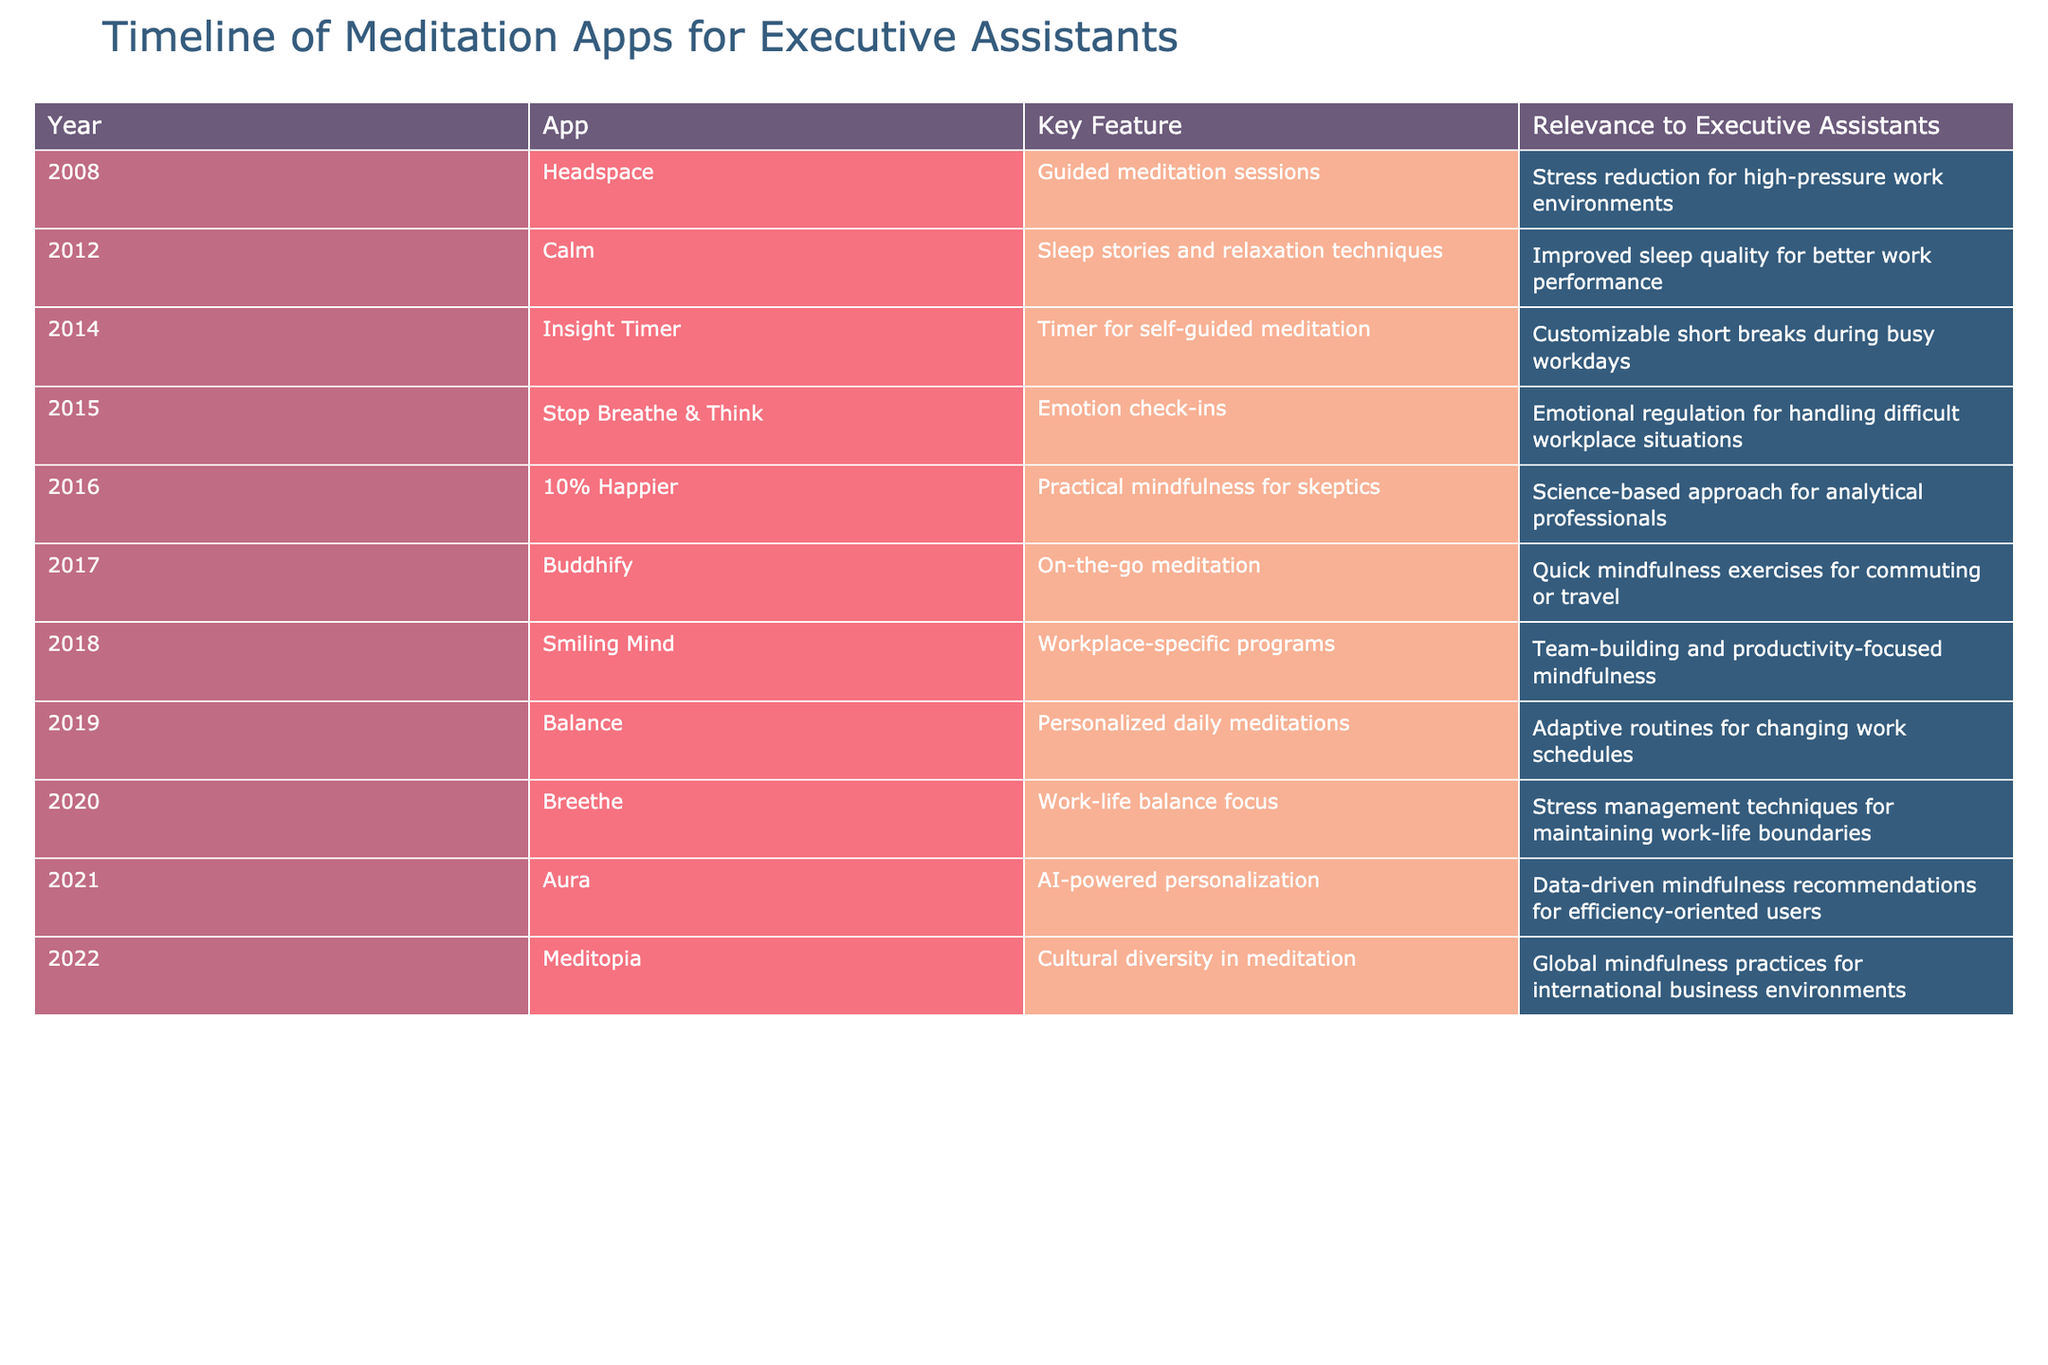What year was Headspace launched? The table shows that Headspace was launched in the year 2008, as indicated in the 'Year' column next to the app name.
Answer: 2008 Which app focuses on workplace-specific programs? According to the table, the app that focuses on workplace-specific programs is Smiling Mind, as noted in the 'App' column alongside the relevant 'Key Feature' column.
Answer: Smiling Mind What is the latest app introduced in the table, and what is its key feature? The last entry in the timeline is Meditopia, which was introduced in 2022. Its key feature, as specified in the table, is cultural diversity in meditation.
Answer: Meditopia, cultural diversity in meditation How many apps were launched between 2012 and 2016? From the table, we can see that Calm (2012), Insight Timer (2014), Stop Breathe & Think (2015), and 10% Happier (2016) were launched during this period. That totals to 4 apps launched.
Answer: 4 Does the app Balance provide stress management techniques? The table indicates that Balance provides personalized daily meditations but does not specifically mention stress management techniques, so the answer is no.
Answer: No Which app has a feature related to emotional regulation? The table specifies that the app Stop Breathe & Think includes emotion check-ins as a key feature, concerning emotional regulation.
Answer: Stop Breathe & Think Which app was designed for on-the-go meditation, and in what year was it released? The app designed for on-the-go meditation is Buddify, launched in 2017, as stated in the respective columns of the table.
Answer: Buddify, 2017 What is the average year of release for apps introduced from 2015 to 2019? Calculating the years gives us: Stop Breathe & Think (2015), Buddify (2017), Smiling Mind (2018), and Balance (2019). The sum is 2015 + 2017 + 2018 + 2019 = 8069. There are 4 entries, so the average is 8069 / 4 = 2017.25, which rounds to 2017.
Answer: 2017 Was there any app released specifically for improving sleep quality? Yes, according to the table, Calm, launched in 2012, includes sleep stories and relaxation techniques aimed at improving sleep quality.
Answer: Yes 